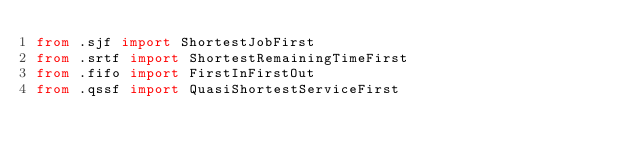Convert code to text. <code><loc_0><loc_0><loc_500><loc_500><_Python_>from .sjf import ShortestJobFirst
from .srtf import ShortestRemainingTimeFirst
from .fifo import FirstInFirstOut
from .qssf import QuasiShortestServiceFirst
</code> 